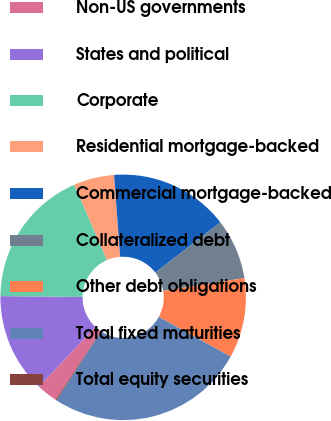<chart> <loc_0><loc_0><loc_500><loc_500><pie_chart><fcel>Non-US governments<fcel>States and political<fcel>Corporate<fcel>Residential mortgage-backed<fcel>Commercial mortgage-backed<fcel>Collateralized debt<fcel>Other debt obligations<fcel>Total fixed maturities<fcel>Total equity securities<nl><fcel>2.73%<fcel>13.13%<fcel>18.33%<fcel>5.33%<fcel>15.73%<fcel>7.93%<fcel>10.53%<fcel>26.14%<fcel>0.13%<nl></chart> 